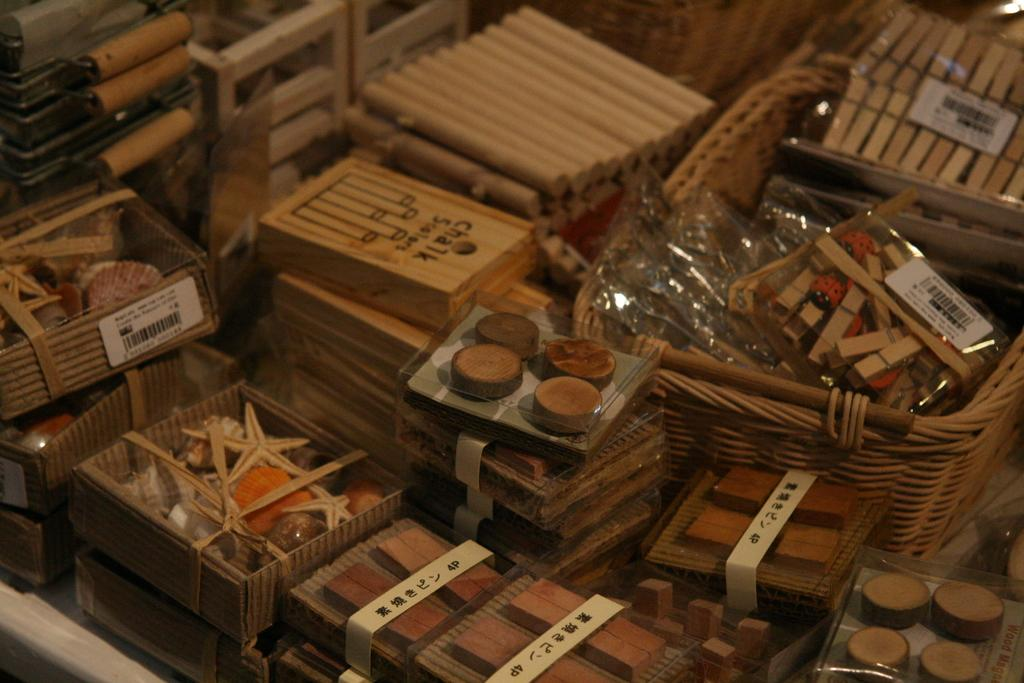What objects are in the center of the image? In the center of the image, there are sticks, clips, wooden boxes, wooden pieces, and a few other objects. What type of material are the sticks made of? The sticks in the image are made of wood. What can be found on some of the objects in the image? Some objects in the image have stickers on them. What other objects can be seen in the center of the image? There are a few other objects in the center of the image, but their specific details are not mentioned in the provided facts. What type of jellyfish can be seen swimming in the image? There are no jellyfish present in the image; it features objects in the center of the image. What type of record is being played in the image? There is no record player or record visible in the image. 